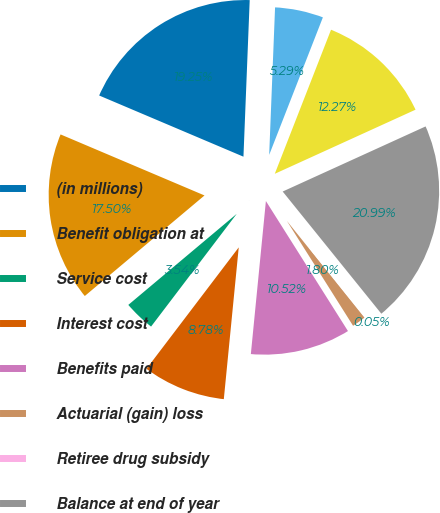Convert chart. <chart><loc_0><loc_0><loc_500><loc_500><pie_chart><fcel>(in millions)<fcel>Benefit obligation at<fcel>Service cost<fcel>Interest cost<fcel>Benefits paid<fcel>Actuarial (gain) loss<fcel>Retiree drug subsidy<fcel>Balance at end of year<fcel>Fair value of plan assets at<fcel>Actual return (loss) on plan<nl><fcel>19.25%<fcel>17.5%<fcel>3.54%<fcel>8.78%<fcel>10.52%<fcel>1.8%<fcel>0.05%<fcel>20.99%<fcel>12.27%<fcel>5.29%<nl></chart> 